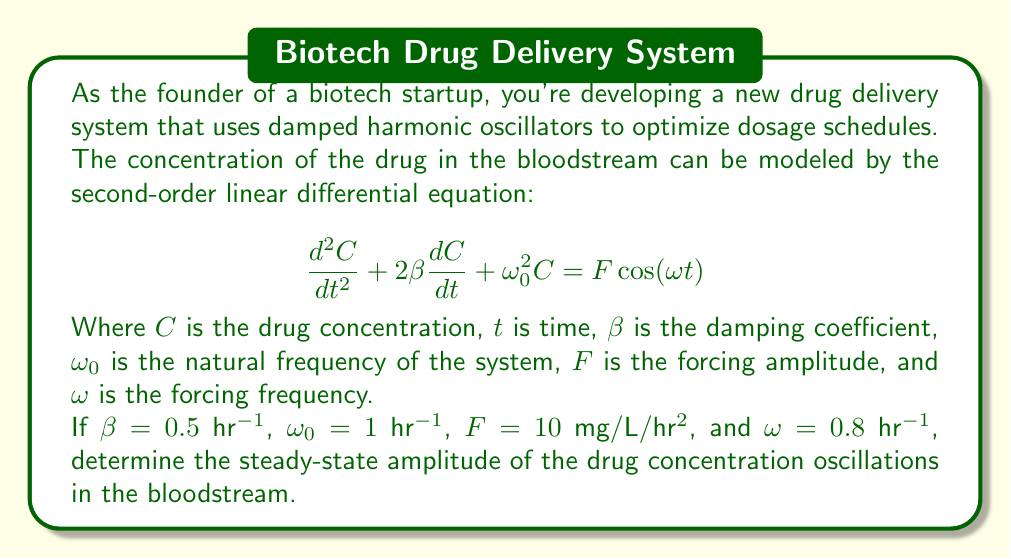Help me with this question. To solve this problem, we need to follow these steps:

1) The steady-state solution for a damped, forced harmonic oscillator has the form:

   $$C(t) = A\cos(\omega t - \phi)$$

   where $A$ is the amplitude we're looking for, and $\phi$ is the phase shift.

2) The amplitude $A$ is given by the formula:

   $$A = \frac{F}{\sqrt{(\omega_0^2 - \omega^2)^2 + 4\beta^2\omega^2}}$$

3) We're given the following values:
   $\beta = 0.5$ hr$^{-1}$
   $\omega_0 = 1$ hr$^{-1}$
   $F = 10$ mg/L/hr$^2$
   $\omega = 0.8$ hr$^{-1}$

4) Let's substitute these values into our amplitude formula:

   $$A = \frac{10}{\sqrt{(1^2 - 0.8^2)^2 + 4(0.5^2)(0.8^2)}}$$

5) Simplify the expression under the square root:
   
   $$A = \frac{10}{\sqrt{(1 - 0.64)^2 + 4(0.25)(0.64)}}$$
   
   $$A = \frac{10}{\sqrt{0.36^2 + 0.64}}$$
   
   $$A = \frac{10}{\sqrt{0.1296 + 0.64}}$$
   
   $$A = \frac{10}{\sqrt{0.7696}}$$

6) Calculate the final result:

   $$A = \frac{10}{0.8774} \approx 11.3969$$

Therefore, the steady-state amplitude of the drug concentration oscillations is approximately 11.3969 mg/L.
Answer: 11.3969 mg/L 